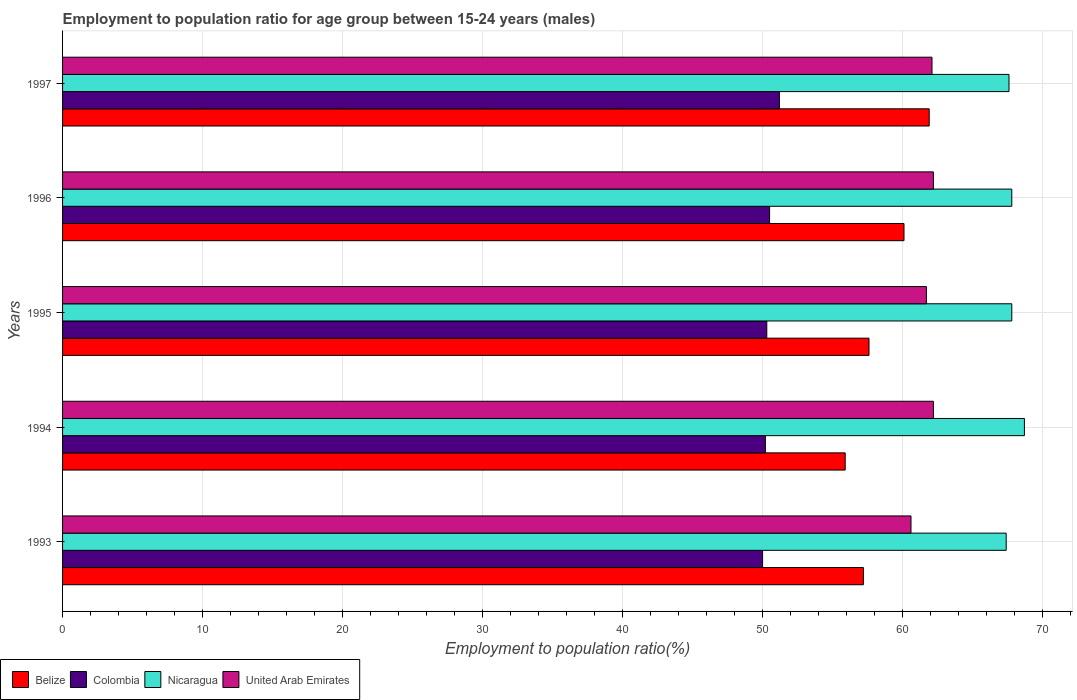How many groups of bars are there?
Your response must be concise. 5. Are the number of bars per tick equal to the number of legend labels?
Provide a succinct answer. Yes. How many bars are there on the 1st tick from the bottom?
Keep it short and to the point. 4. In how many cases, is the number of bars for a given year not equal to the number of legend labels?
Your response must be concise. 0. What is the employment to population ratio in Belize in 1993?
Keep it short and to the point. 57.2. Across all years, what is the maximum employment to population ratio in Belize?
Give a very brief answer. 61.9. Across all years, what is the minimum employment to population ratio in Nicaragua?
Make the answer very short. 67.4. In which year was the employment to population ratio in Belize minimum?
Offer a very short reply. 1994. What is the total employment to population ratio in United Arab Emirates in the graph?
Give a very brief answer. 308.8. What is the difference between the employment to population ratio in Nicaragua in 1996 and that in 1997?
Offer a terse response. 0.2. What is the difference between the employment to population ratio in Colombia in 1993 and the employment to population ratio in United Arab Emirates in 1997?
Keep it short and to the point. -12.1. What is the average employment to population ratio in Belize per year?
Make the answer very short. 58.54. In the year 1995, what is the difference between the employment to population ratio in United Arab Emirates and employment to population ratio in Belize?
Give a very brief answer. 4.1. What is the ratio of the employment to population ratio in Belize in 1993 to that in 1995?
Keep it short and to the point. 0.99. Is the difference between the employment to population ratio in United Arab Emirates in 1994 and 1996 greater than the difference between the employment to population ratio in Belize in 1994 and 1996?
Provide a succinct answer. Yes. What is the difference between the highest and the lowest employment to population ratio in Belize?
Your answer should be very brief. 6. Is the sum of the employment to population ratio in Colombia in 1993 and 1996 greater than the maximum employment to population ratio in Belize across all years?
Give a very brief answer. Yes. Is it the case that in every year, the sum of the employment to population ratio in Nicaragua and employment to population ratio in Belize is greater than the sum of employment to population ratio in Colombia and employment to population ratio in United Arab Emirates?
Provide a short and direct response. Yes. What does the 4th bar from the top in 1993 represents?
Keep it short and to the point. Belize. What does the 3rd bar from the bottom in 1997 represents?
Keep it short and to the point. Nicaragua. How many bars are there?
Your answer should be compact. 20. How many years are there in the graph?
Offer a very short reply. 5. Are the values on the major ticks of X-axis written in scientific E-notation?
Your answer should be compact. No. Does the graph contain any zero values?
Your response must be concise. No. Does the graph contain grids?
Offer a very short reply. Yes. Where does the legend appear in the graph?
Your answer should be very brief. Bottom left. What is the title of the graph?
Your response must be concise. Employment to population ratio for age group between 15-24 years (males). Does "Cambodia" appear as one of the legend labels in the graph?
Your answer should be compact. No. What is the label or title of the X-axis?
Provide a short and direct response. Employment to population ratio(%). What is the label or title of the Y-axis?
Keep it short and to the point. Years. What is the Employment to population ratio(%) in Belize in 1993?
Keep it short and to the point. 57.2. What is the Employment to population ratio(%) in Colombia in 1993?
Ensure brevity in your answer.  50. What is the Employment to population ratio(%) in Nicaragua in 1993?
Give a very brief answer. 67.4. What is the Employment to population ratio(%) in United Arab Emirates in 1993?
Your response must be concise. 60.6. What is the Employment to population ratio(%) of Belize in 1994?
Your response must be concise. 55.9. What is the Employment to population ratio(%) of Colombia in 1994?
Ensure brevity in your answer.  50.2. What is the Employment to population ratio(%) in Nicaragua in 1994?
Your response must be concise. 68.7. What is the Employment to population ratio(%) of United Arab Emirates in 1994?
Make the answer very short. 62.2. What is the Employment to population ratio(%) of Belize in 1995?
Offer a terse response. 57.6. What is the Employment to population ratio(%) of Colombia in 1995?
Your answer should be very brief. 50.3. What is the Employment to population ratio(%) of Nicaragua in 1995?
Your response must be concise. 67.8. What is the Employment to population ratio(%) in United Arab Emirates in 1995?
Make the answer very short. 61.7. What is the Employment to population ratio(%) in Belize in 1996?
Make the answer very short. 60.1. What is the Employment to population ratio(%) of Colombia in 1996?
Provide a short and direct response. 50.5. What is the Employment to population ratio(%) in Nicaragua in 1996?
Ensure brevity in your answer.  67.8. What is the Employment to population ratio(%) of United Arab Emirates in 1996?
Give a very brief answer. 62.2. What is the Employment to population ratio(%) in Belize in 1997?
Provide a short and direct response. 61.9. What is the Employment to population ratio(%) of Colombia in 1997?
Ensure brevity in your answer.  51.2. What is the Employment to population ratio(%) in Nicaragua in 1997?
Ensure brevity in your answer.  67.6. What is the Employment to population ratio(%) in United Arab Emirates in 1997?
Ensure brevity in your answer.  62.1. Across all years, what is the maximum Employment to population ratio(%) in Belize?
Make the answer very short. 61.9. Across all years, what is the maximum Employment to population ratio(%) in Colombia?
Your response must be concise. 51.2. Across all years, what is the maximum Employment to population ratio(%) of Nicaragua?
Your answer should be very brief. 68.7. Across all years, what is the maximum Employment to population ratio(%) in United Arab Emirates?
Make the answer very short. 62.2. Across all years, what is the minimum Employment to population ratio(%) of Belize?
Your answer should be compact. 55.9. Across all years, what is the minimum Employment to population ratio(%) in Nicaragua?
Make the answer very short. 67.4. Across all years, what is the minimum Employment to population ratio(%) of United Arab Emirates?
Your response must be concise. 60.6. What is the total Employment to population ratio(%) in Belize in the graph?
Offer a very short reply. 292.7. What is the total Employment to population ratio(%) in Colombia in the graph?
Your response must be concise. 252.2. What is the total Employment to population ratio(%) of Nicaragua in the graph?
Your response must be concise. 339.3. What is the total Employment to population ratio(%) in United Arab Emirates in the graph?
Offer a terse response. 308.8. What is the difference between the Employment to population ratio(%) in Colombia in 1993 and that in 1994?
Keep it short and to the point. -0.2. What is the difference between the Employment to population ratio(%) in Nicaragua in 1993 and that in 1994?
Your answer should be very brief. -1.3. What is the difference between the Employment to population ratio(%) in Belize in 1993 and that in 1995?
Make the answer very short. -0.4. What is the difference between the Employment to population ratio(%) of Colombia in 1993 and that in 1996?
Your answer should be very brief. -0.5. What is the difference between the Employment to population ratio(%) in Nicaragua in 1993 and that in 1996?
Provide a short and direct response. -0.4. What is the difference between the Employment to population ratio(%) of United Arab Emirates in 1993 and that in 1996?
Provide a short and direct response. -1.6. What is the difference between the Employment to population ratio(%) in Belize in 1993 and that in 1997?
Make the answer very short. -4.7. What is the difference between the Employment to population ratio(%) of Nicaragua in 1993 and that in 1997?
Give a very brief answer. -0.2. What is the difference between the Employment to population ratio(%) in Belize in 1994 and that in 1995?
Keep it short and to the point. -1.7. What is the difference between the Employment to population ratio(%) in Belize in 1994 and that in 1996?
Provide a succinct answer. -4.2. What is the difference between the Employment to population ratio(%) in Nicaragua in 1994 and that in 1996?
Your answer should be very brief. 0.9. What is the difference between the Employment to population ratio(%) in Belize in 1994 and that in 1997?
Give a very brief answer. -6. What is the difference between the Employment to population ratio(%) of Nicaragua in 1994 and that in 1997?
Your response must be concise. 1.1. What is the difference between the Employment to population ratio(%) in United Arab Emirates in 1994 and that in 1997?
Provide a short and direct response. 0.1. What is the difference between the Employment to population ratio(%) in United Arab Emirates in 1995 and that in 1996?
Make the answer very short. -0.5. What is the difference between the Employment to population ratio(%) in United Arab Emirates in 1995 and that in 1997?
Make the answer very short. -0.4. What is the difference between the Employment to population ratio(%) in Colombia in 1996 and that in 1997?
Give a very brief answer. -0.7. What is the difference between the Employment to population ratio(%) in Nicaragua in 1996 and that in 1997?
Provide a succinct answer. 0.2. What is the difference between the Employment to population ratio(%) of United Arab Emirates in 1996 and that in 1997?
Provide a short and direct response. 0.1. What is the difference between the Employment to population ratio(%) of Belize in 1993 and the Employment to population ratio(%) of Colombia in 1994?
Your response must be concise. 7. What is the difference between the Employment to population ratio(%) in Belize in 1993 and the Employment to population ratio(%) in Nicaragua in 1994?
Your answer should be compact. -11.5. What is the difference between the Employment to population ratio(%) of Belize in 1993 and the Employment to population ratio(%) of United Arab Emirates in 1994?
Offer a terse response. -5. What is the difference between the Employment to population ratio(%) in Colombia in 1993 and the Employment to population ratio(%) in Nicaragua in 1994?
Your response must be concise. -18.7. What is the difference between the Employment to population ratio(%) of Belize in 1993 and the Employment to population ratio(%) of Colombia in 1995?
Your answer should be very brief. 6.9. What is the difference between the Employment to population ratio(%) in Belize in 1993 and the Employment to population ratio(%) in Nicaragua in 1995?
Give a very brief answer. -10.6. What is the difference between the Employment to population ratio(%) in Belize in 1993 and the Employment to population ratio(%) in United Arab Emirates in 1995?
Provide a short and direct response. -4.5. What is the difference between the Employment to population ratio(%) in Colombia in 1993 and the Employment to population ratio(%) in Nicaragua in 1995?
Offer a very short reply. -17.8. What is the difference between the Employment to population ratio(%) in Colombia in 1993 and the Employment to population ratio(%) in United Arab Emirates in 1995?
Provide a short and direct response. -11.7. What is the difference between the Employment to population ratio(%) in Nicaragua in 1993 and the Employment to population ratio(%) in United Arab Emirates in 1995?
Provide a short and direct response. 5.7. What is the difference between the Employment to population ratio(%) of Belize in 1993 and the Employment to population ratio(%) of Colombia in 1996?
Ensure brevity in your answer.  6.7. What is the difference between the Employment to population ratio(%) in Belize in 1993 and the Employment to population ratio(%) in Nicaragua in 1996?
Make the answer very short. -10.6. What is the difference between the Employment to population ratio(%) of Belize in 1993 and the Employment to population ratio(%) of United Arab Emirates in 1996?
Your response must be concise. -5. What is the difference between the Employment to population ratio(%) of Colombia in 1993 and the Employment to population ratio(%) of Nicaragua in 1996?
Offer a terse response. -17.8. What is the difference between the Employment to population ratio(%) of Colombia in 1993 and the Employment to population ratio(%) of United Arab Emirates in 1996?
Ensure brevity in your answer.  -12.2. What is the difference between the Employment to population ratio(%) of Nicaragua in 1993 and the Employment to population ratio(%) of United Arab Emirates in 1996?
Make the answer very short. 5.2. What is the difference between the Employment to population ratio(%) of Belize in 1993 and the Employment to population ratio(%) of United Arab Emirates in 1997?
Make the answer very short. -4.9. What is the difference between the Employment to population ratio(%) of Colombia in 1993 and the Employment to population ratio(%) of Nicaragua in 1997?
Offer a terse response. -17.6. What is the difference between the Employment to population ratio(%) of Colombia in 1993 and the Employment to population ratio(%) of United Arab Emirates in 1997?
Your response must be concise. -12.1. What is the difference between the Employment to population ratio(%) in Belize in 1994 and the Employment to population ratio(%) in Colombia in 1995?
Make the answer very short. 5.6. What is the difference between the Employment to population ratio(%) in Colombia in 1994 and the Employment to population ratio(%) in Nicaragua in 1995?
Your response must be concise. -17.6. What is the difference between the Employment to population ratio(%) in Colombia in 1994 and the Employment to population ratio(%) in United Arab Emirates in 1995?
Provide a succinct answer. -11.5. What is the difference between the Employment to population ratio(%) of Belize in 1994 and the Employment to population ratio(%) of Colombia in 1996?
Ensure brevity in your answer.  5.4. What is the difference between the Employment to population ratio(%) of Belize in 1994 and the Employment to population ratio(%) of Nicaragua in 1996?
Your response must be concise. -11.9. What is the difference between the Employment to population ratio(%) in Belize in 1994 and the Employment to population ratio(%) in United Arab Emirates in 1996?
Keep it short and to the point. -6.3. What is the difference between the Employment to population ratio(%) in Colombia in 1994 and the Employment to population ratio(%) in Nicaragua in 1996?
Provide a succinct answer. -17.6. What is the difference between the Employment to population ratio(%) of Colombia in 1994 and the Employment to population ratio(%) of United Arab Emirates in 1996?
Give a very brief answer. -12. What is the difference between the Employment to population ratio(%) in Nicaragua in 1994 and the Employment to population ratio(%) in United Arab Emirates in 1996?
Offer a very short reply. 6.5. What is the difference between the Employment to population ratio(%) in Belize in 1994 and the Employment to population ratio(%) in Nicaragua in 1997?
Your answer should be compact. -11.7. What is the difference between the Employment to population ratio(%) of Colombia in 1994 and the Employment to population ratio(%) of Nicaragua in 1997?
Provide a succinct answer. -17.4. What is the difference between the Employment to population ratio(%) of Colombia in 1994 and the Employment to population ratio(%) of United Arab Emirates in 1997?
Your response must be concise. -11.9. What is the difference between the Employment to population ratio(%) in Belize in 1995 and the Employment to population ratio(%) in Nicaragua in 1996?
Offer a terse response. -10.2. What is the difference between the Employment to population ratio(%) of Colombia in 1995 and the Employment to population ratio(%) of Nicaragua in 1996?
Provide a succinct answer. -17.5. What is the difference between the Employment to population ratio(%) in Belize in 1995 and the Employment to population ratio(%) in Nicaragua in 1997?
Make the answer very short. -10. What is the difference between the Employment to population ratio(%) of Belize in 1995 and the Employment to population ratio(%) of United Arab Emirates in 1997?
Your answer should be compact. -4.5. What is the difference between the Employment to population ratio(%) in Colombia in 1995 and the Employment to population ratio(%) in Nicaragua in 1997?
Make the answer very short. -17.3. What is the difference between the Employment to population ratio(%) in Belize in 1996 and the Employment to population ratio(%) in Nicaragua in 1997?
Provide a short and direct response. -7.5. What is the difference between the Employment to population ratio(%) of Colombia in 1996 and the Employment to population ratio(%) of Nicaragua in 1997?
Your answer should be very brief. -17.1. What is the average Employment to population ratio(%) in Belize per year?
Provide a short and direct response. 58.54. What is the average Employment to population ratio(%) in Colombia per year?
Your response must be concise. 50.44. What is the average Employment to population ratio(%) in Nicaragua per year?
Your response must be concise. 67.86. What is the average Employment to population ratio(%) in United Arab Emirates per year?
Provide a short and direct response. 61.76. In the year 1993, what is the difference between the Employment to population ratio(%) in Belize and Employment to population ratio(%) in Nicaragua?
Keep it short and to the point. -10.2. In the year 1993, what is the difference between the Employment to population ratio(%) in Colombia and Employment to population ratio(%) in Nicaragua?
Offer a terse response. -17.4. In the year 1993, what is the difference between the Employment to population ratio(%) in Colombia and Employment to population ratio(%) in United Arab Emirates?
Give a very brief answer. -10.6. In the year 1993, what is the difference between the Employment to population ratio(%) in Nicaragua and Employment to population ratio(%) in United Arab Emirates?
Offer a terse response. 6.8. In the year 1994, what is the difference between the Employment to population ratio(%) of Belize and Employment to population ratio(%) of Nicaragua?
Your answer should be compact. -12.8. In the year 1994, what is the difference between the Employment to population ratio(%) in Belize and Employment to population ratio(%) in United Arab Emirates?
Your answer should be compact. -6.3. In the year 1994, what is the difference between the Employment to population ratio(%) in Colombia and Employment to population ratio(%) in Nicaragua?
Provide a short and direct response. -18.5. In the year 1994, what is the difference between the Employment to population ratio(%) of Colombia and Employment to population ratio(%) of United Arab Emirates?
Keep it short and to the point. -12. In the year 1994, what is the difference between the Employment to population ratio(%) of Nicaragua and Employment to population ratio(%) of United Arab Emirates?
Offer a terse response. 6.5. In the year 1995, what is the difference between the Employment to population ratio(%) in Belize and Employment to population ratio(%) in Colombia?
Provide a succinct answer. 7.3. In the year 1995, what is the difference between the Employment to population ratio(%) in Belize and Employment to population ratio(%) in Nicaragua?
Keep it short and to the point. -10.2. In the year 1995, what is the difference between the Employment to population ratio(%) in Belize and Employment to population ratio(%) in United Arab Emirates?
Keep it short and to the point. -4.1. In the year 1995, what is the difference between the Employment to population ratio(%) of Colombia and Employment to population ratio(%) of Nicaragua?
Keep it short and to the point. -17.5. In the year 1995, what is the difference between the Employment to population ratio(%) in Colombia and Employment to population ratio(%) in United Arab Emirates?
Your answer should be compact. -11.4. In the year 1995, what is the difference between the Employment to population ratio(%) of Nicaragua and Employment to population ratio(%) of United Arab Emirates?
Provide a succinct answer. 6.1. In the year 1996, what is the difference between the Employment to population ratio(%) in Belize and Employment to population ratio(%) in Nicaragua?
Offer a very short reply. -7.7. In the year 1996, what is the difference between the Employment to population ratio(%) in Colombia and Employment to population ratio(%) in Nicaragua?
Your response must be concise. -17.3. In the year 1996, what is the difference between the Employment to population ratio(%) in Colombia and Employment to population ratio(%) in United Arab Emirates?
Your answer should be very brief. -11.7. In the year 1997, what is the difference between the Employment to population ratio(%) of Belize and Employment to population ratio(%) of Colombia?
Offer a very short reply. 10.7. In the year 1997, what is the difference between the Employment to population ratio(%) in Colombia and Employment to population ratio(%) in Nicaragua?
Provide a short and direct response. -16.4. In the year 1997, what is the difference between the Employment to population ratio(%) of Nicaragua and Employment to population ratio(%) of United Arab Emirates?
Make the answer very short. 5.5. What is the ratio of the Employment to population ratio(%) of Belize in 1993 to that in 1994?
Your answer should be very brief. 1.02. What is the ratio of the Employment to population ratio(%) in Colombia in 1993 to that in 1994?
Make the answer very short. 1. What is the ratio of the Employment to population ratio(%) of Nicaragua in 1993 to that in 1994?
Make the answer very short. 0.98. What is the ratio of the Employment to population ratio(%) in United Arab Emirates in 1993 to that in 1994?
Your response must be concise. 0.97. What is the ratio of the Employment to population ratio(%) of Colombia in 1993 to that in 1995?
Keep it short and to the point. 0.99. What is the ratio of the Employment to population ratio(%) of Nicaragua in 1993 to that in 1995?
Give a very brief answer. 0.99. What is the ratio of the Employment to population ratio(%) in United Arab Emirates in 1993 to that in 1995?
Your answer should be very brief. 0.98. What is the ratio of the Employment to population ratio(%) of Belize in 1993 to that in 1996?
Your answer should be very brief. 0.95. What is the ratio of the Employment to population ratio(%) in United Arab Emirates in 1993 to that in 1996?
Ensure brevity in your answer.  0.97. What is the ratio of the Employment to population ratio(%) in Belize in 1993 to that in 1997?
Ensure brevity in your answer.  0.92. What is the ratio of the Employment to population ratio(%) in Colombia in 1993 to that in 1997?
Provide a succinct answer. 0.98. What is the ratio of the Employment to population ratio(%) in United Arab Emirates in 1993 to that in 1997?
Keep it short and to the point. 0.98. What is the ratio of the Employment to population ratio(%) in Belize in 1994 to that in 1995?
Your answer should be compact. 0.97. What is the ratio of the Employment to population ratio(%) of Nicaragua in 1994 to that in 1995?
Give a very brief answer. 1.01. What is the ratio of the Employment to population ratio(%) in United Arab Emirates in 1994 to that in 1995?
Your answer should be compact. 1.01. What is the ratio of the Employment to population ratio(%) in Belize in 1994 to that in 1996?
Offer a very short reply. 0.93. What is the ratio of the Employment to population ratio(%) of Nicaragua in 1994 to that in 1996?
Offer a terse response. 1.01. What is the ratio of the Employment to population ratio(%) of United Arab Emirates in 1994 to that in 1996?
Provide a short and direct response. 1. What is the ratio of the Employment to population ratio(%) of Belize in 1994 to that in 1997?
Ensure brevity in your answer.  0.9. What is the ratio of the Employment to population ratio(%) of Colombia in 1994 to that in 1997?
Offer a very short reply. 0.98. What is the ratio of the Employment to population ratio(%) in Nicaragua in 1994 to that in 1997?
Your answer should be very brief. 1.02. What is the ratio of the Employment to population ratio(%) in Belize in 1995 to that in 1996?
Offer a terse response. 0.96. What is the ratio of the Employment to population ratio(%) of United Arab Emirates in 1995 to that in 1996?
Offer a terse response. 0.99. What is the ratio of the Employment to population ratio(%) of Belize in 1995 to that in 1997?
Your response must be concise. 0.93. What is the ratio of the Employment to population ratio(%) of Colombia in 1995 to that in 1997?
Give a very brief answer. 0.98. What is the ratio of the Employment to population ratio(%) of United Arab Emirates in 1995 to that in 1997?
Ensure brevity in your answer.  0.99. What is the ratio of the Employment to population ratio(%) in Belize in 1996 to that in 1997?
Provide a short and direct response. 0.97. What is the ratio of the Employment to population ratio(%) in Colombia in 1996 to that in 1997?
Ensure brevity in your answer.  0.99. What is the ratio of the Employment to population ratio(%) in Nicaragua in 1996 to that in 1997?
Your answer should be compact. 1. What is the ratio of the Employment to population ratio(%) in United Arab Emirates in 1996 to that in 1997?
Your answer should be very brief. 1. What is the difference between the highest and the second highest Employment to population ratio(%) in Belize?
Give a very brief answer. 1.8. What is the difference between the highest and the second highest Employment to population ratio(%) of Nicaragua?
Your answer should be very brief. 0.9. What is the difference between the highest and the second highest Employment to population ratio(%) in United Arab Emirates?
Your response must be concise. 0. What is the difference between the highest and the lowest Employment to population ratio(%) in Belize?
Your response must be concise. 6. What is the difference between the highest and the lowest Employment to population ratio(%) of Colombia?
Your response must be concise. 1.2. What is the difference between the highest and the lowest Employment to population ratio(%) in United Arab Emirates?
Your response must be concise. 1.6. 